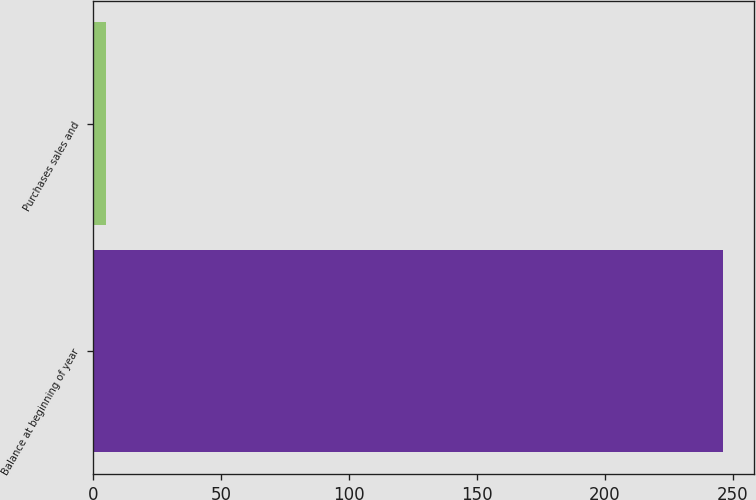Convert chart. <chart><loc_0><loc_0><loc_500><loc_500><bar_chart><fcel>Balance at beginning of year<fcel>Purchases sales and<nl><fcel>246<fcel>5<nl></chart> 